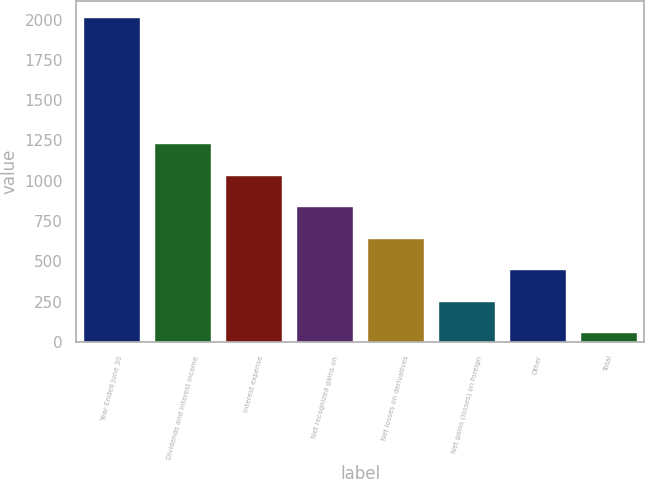<chart> <loc_0><loc_0><loc_500><loc_500><bar_chart><fcel>Year Ended June 30<fcel>Dividends and interest income<fcel>Interest expense<fcel>Net recognized gains on<fcel>Net losses on derivatives<fcel>Net gains (losses) on foreign<fcel>Other<fcel>Total<nl><fcel>2014<fcel>1232.8<fcel>1037.5<fcel>842.2<fcel>646.9<fcel>256.3<fcel>451.6<fcel>61<nl></chart> 